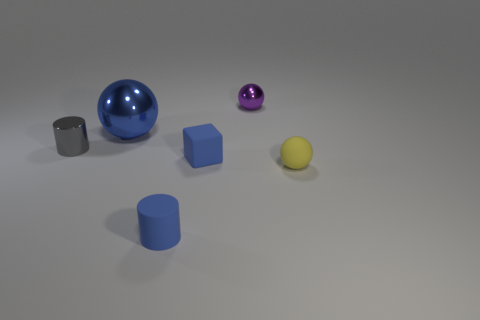Subtract all small matte spheres. How many spheres are left? 2 Add 4 small yellow spheres. How many objects exist? 10 Subtract all gray cylinders. How many cylinders are left? 1 Subtract all brown cylinders. Subtract all blue spheres. How many cylinders are left? 2 Subtract 1 purple balls. How many objects are left? 5 Subtract all cubes. How many objects are left? 5 Subtract all big blue things. Subtract all large blue metallic things. How many objects are left? 4 Add 2 tiny gray things. How many tiny gray things are left? 3 Add 1 big blue cylinders. How many big blue cylinders exist? 1 